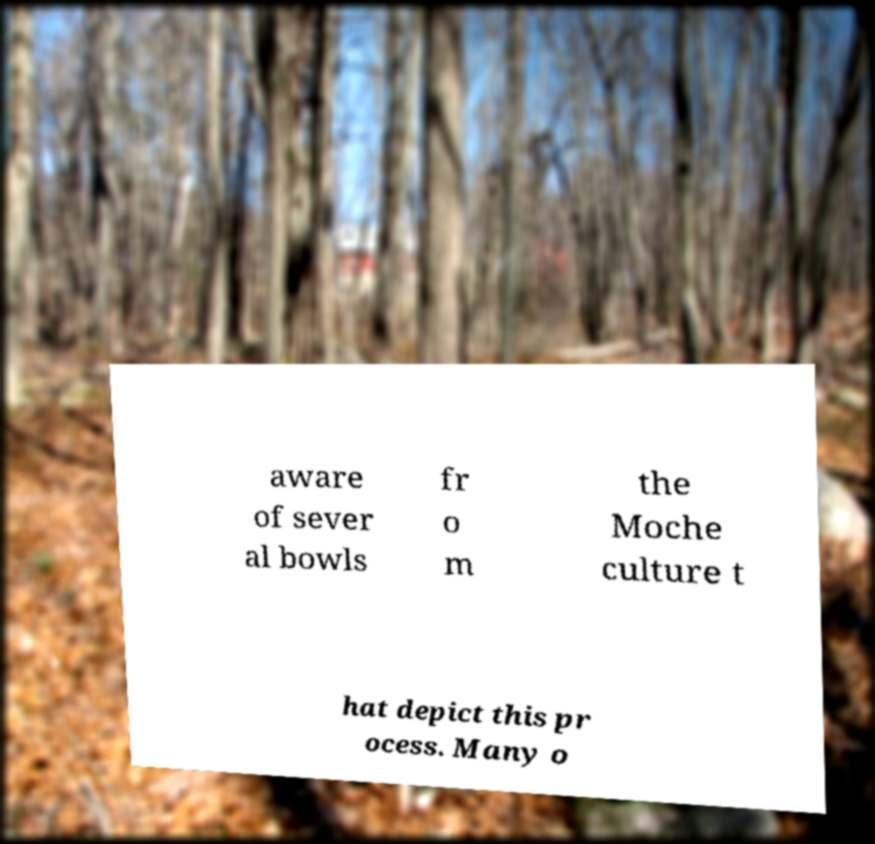Please read and relay the text visible in this image. What does it say? aware of sever al bowls fr o m the Moche culture t hat depict this pr ocess. Many o 